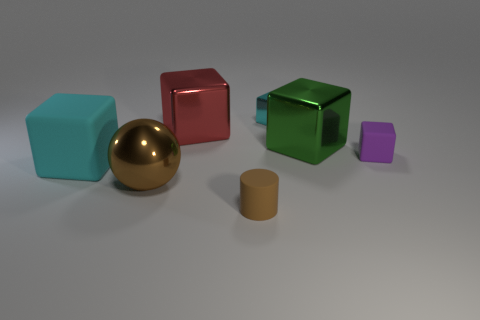Subtract all purple cubes. How many cubes are left? 4 Subtract all big red cubes. How many cubes are left? 4 Subtract all brown cubes. Subtract all cyan balls. How many cubes are left? 5 Add 1 brown shiny objects. How many objects exist? 8 Subtract all blocks. How many objects are left? 2 Subtract all purple matte blocks. Subtract all tiny blocks. How many objects are left? 4 Add 7 large red metallic blocks. How many large red metallic blocks are left? 8 Add 6 cylinders. How many cylinders exist? 7 Subtract 0 blue balls. How many objects are left? 7 